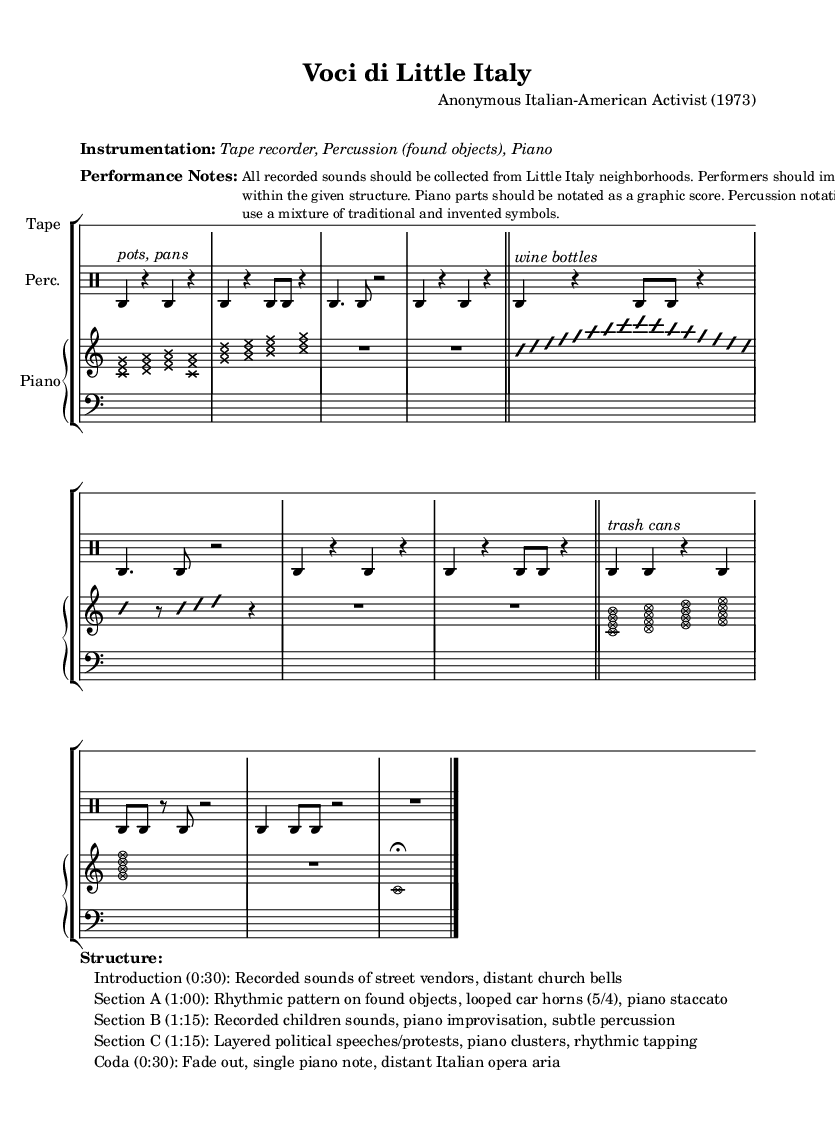What is the title of this piece? The title "Voci di Little Italy" is indicated at the top of the sheet music under the header section.
Answer: Voci di Little Italy What is the time signature of the piece? The time signature is listed as 4/4 at the beginning of the music for each staff, confirming the rhythmic structure throughout the piece.
Answer: 4/4 What instruments are indicated for this performance? The instruments are specified in the instrumentation markup section, where "Tape recorder, Percussion (found objects), Piano" are listed as the required instruments.
Answer: Tape recorder, Percussion (found objects), Piano How long is the Introduction section? The structure section details the length of the Introduction as 30 seconds, providing clear timing for that part of the composition.
Answer: 0:30 Which unconventional materials are suggested for percussion? The percussion section specifies "pots, pans," "wine bottles," and "trash cans" as unconventional objects to be used, emphasizing the experimental nature of the piece.
Answer: pots, pans, wine bottles, trash cans What is the purpose of using recorded sounds in this piece? The performance notes state that all recorded sounds should be collected from Little Italy neighborhoods, indicating the intent to incorporate localized street sounds for an authentic atmosphere.
Answer: Authentic atmosphere What is the final sound in the Coda? The structure section reveals that the Coda features a "single piano note" and a "distant Italian opera aria," emphasizing a reflective closing moment.
Answer: single piano note, distant Italian opera aria 